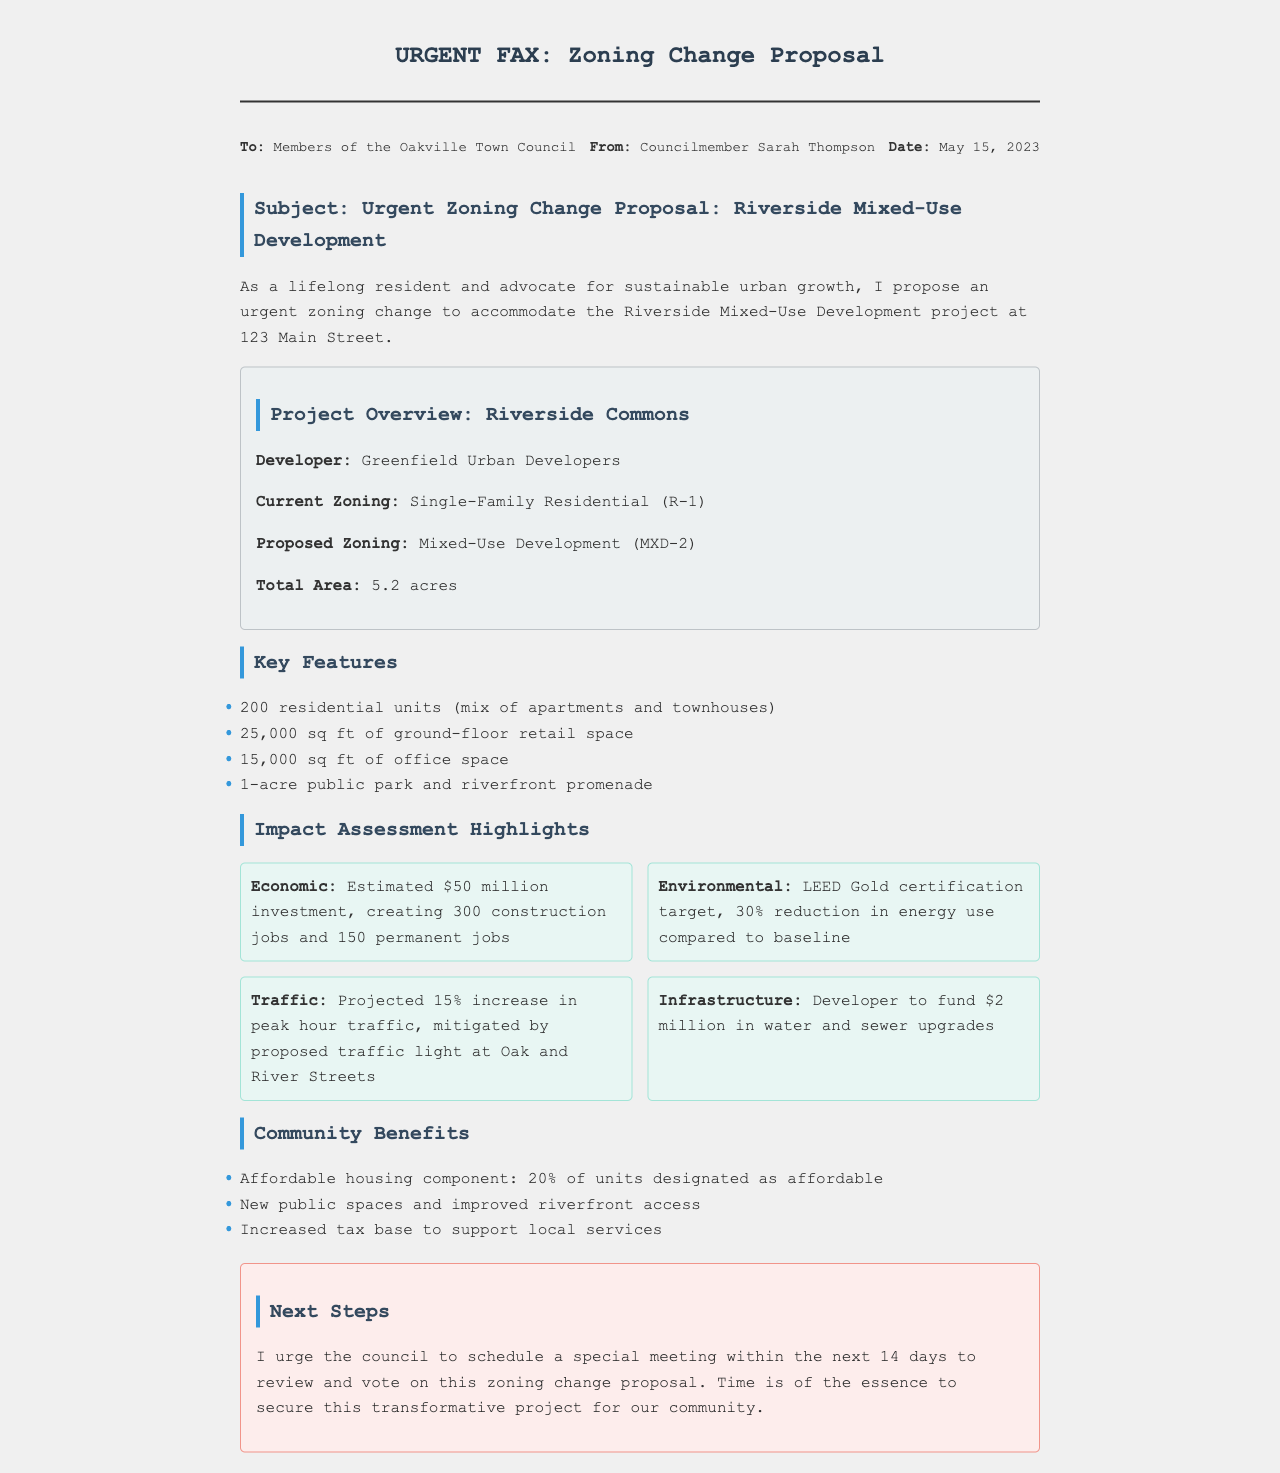What is the developer's name? The developer's name is listed as the company responsible for the project in the document.
Answer: Greenfield Urban Developers What is the proposed zoning change? The proposed zoning change is the new zoning classification indicated in the document.
Answer: Mixed-Use Development (MXD-2) What is the total area of the development? The total area is specified as part of the project overview section in the document.
Answer: 5.2 acres How many residential units are included in the project? The number of residential units is detailed in the key features section of the document.
Answer: 200 residential units What is the target LEED certification for the project? The LEED certification target is mentioned in the environmental impact assessment section of the document.
Answer: LEED Gold What percentage of units will be affordable housing? The percentage of affordable housing units is mentioned under community benefits in the document.
Answer: 20% How much funding will the developer provide for water and sewer upgrades? The funding amount for infrastructure upgrades is detailed in the impact assessment section of the document.
Answer: $2 million What is the projected increase in peak hour traffic? The projected traffic increase is indicated in the traffic impact assessment section of the document.
Answer: 15% When does the council need to schedule a special meeting? The timeframe for scheduling the meeting is indicated in the next steps section of the document.
Answer: Within the next 14 days 